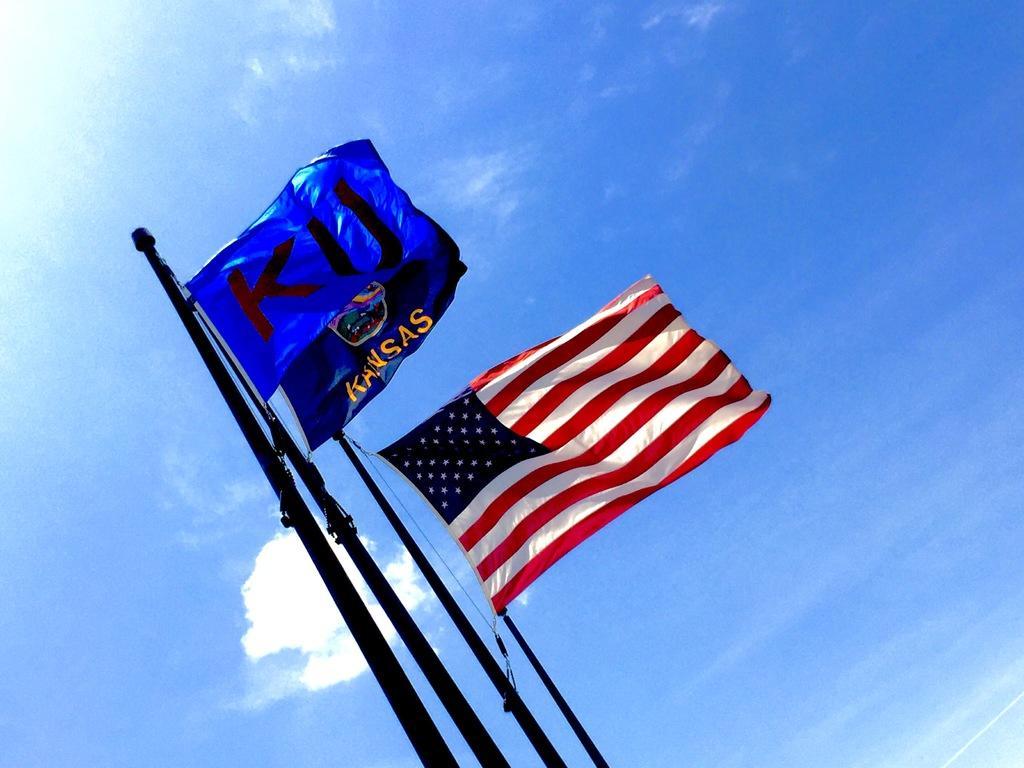How would you summarize this image in a sentence or two? In this picture there are flags on the poles. At the top there is sky and there are clouds and there is text on the flags. 